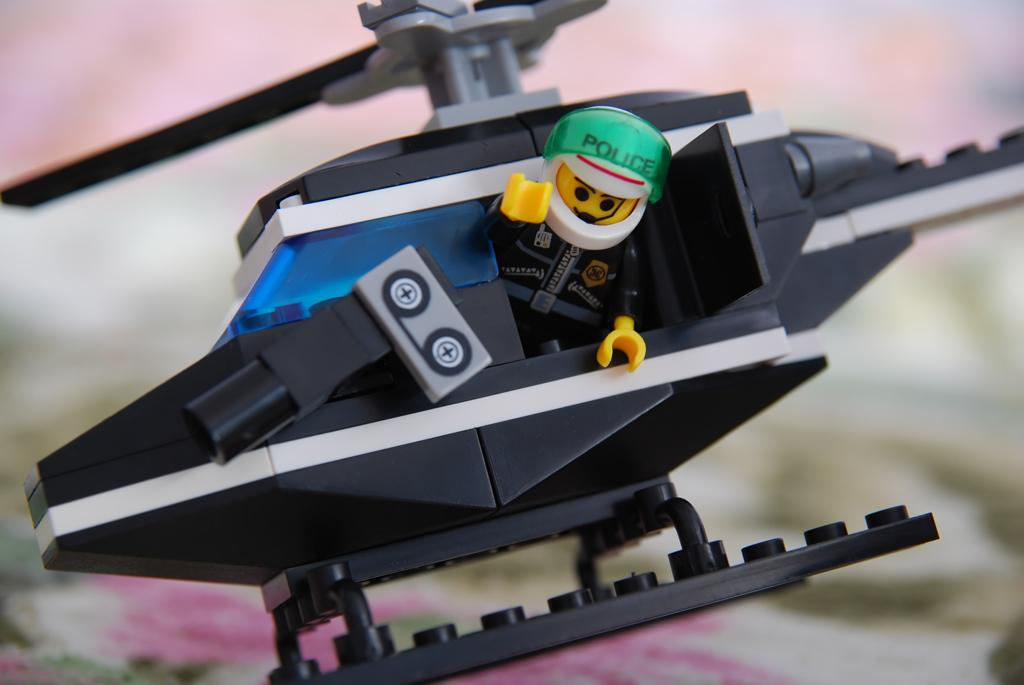What type of toy is in the image? There is a plastic plane in the image, which is also a toy. Where are the plastic plane and the toy located? Both the plastic plane and the toy are on a bed. What can be seen at the bottom of the bed? There is a bed sheet visible at the bottom of the bed. How does the plastic plane exchange information with the toy in the image? The plastic plane and the toy are not capable of exchanging information, as they are inanimate objects. 